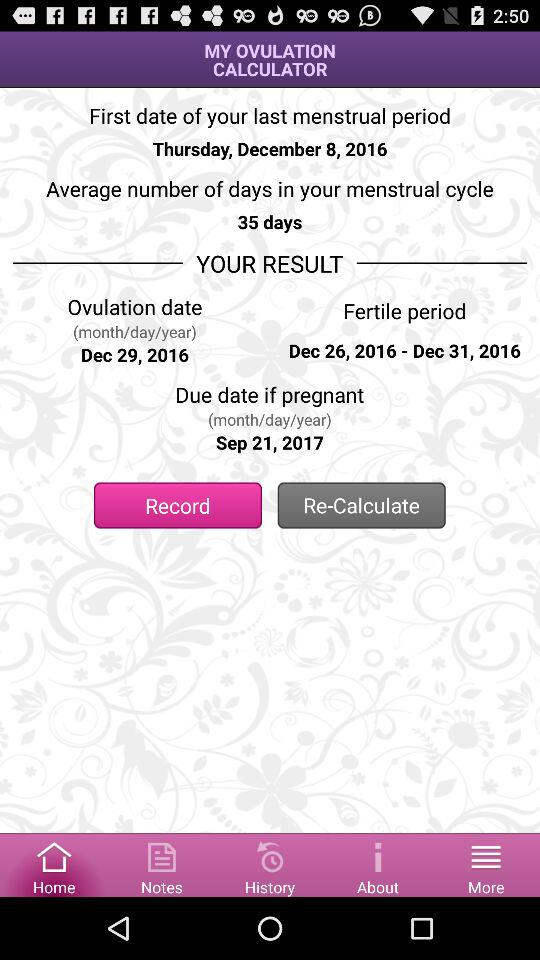What is the result shown on the screen for ovulation date? The result shown on the screen for ovulation date is December 29, 2016. 